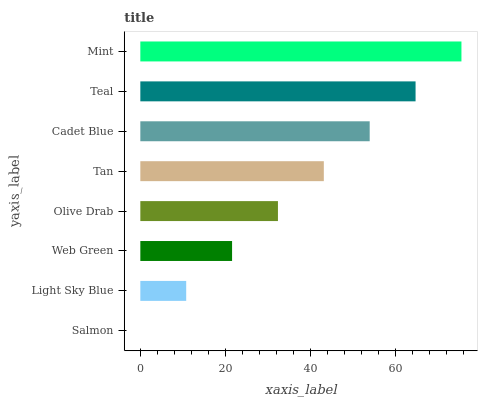Is Salmon the minimum?
Answer yes or no. Yes. Is Mint the maximum?
Answer yes or no. Yes. Is Light Sky Blue the minimum?
Answer yes or no. No. Is Light Sky Blue the maximum?
Answer yes or no. No. Is Light Sky Blue greater than Salmon?
Answer yes or no. Yes. Is Salmon less than Light Sky Blue?
Answer yes or no. Yes. Is Salmon greater than Light Sky Blue?
Answer yes or no. No. Is Light Sky Blue less than Salmon?
Answer yes or no. No. Is Tan the high median?
Answer yes or no. Yes. Is Olive Drab the low median?
Answer yes or no. Yes. Is Web Green the high median?
Answer yes or no. No. Is Mint the low median?
Answer yes or no. No. 